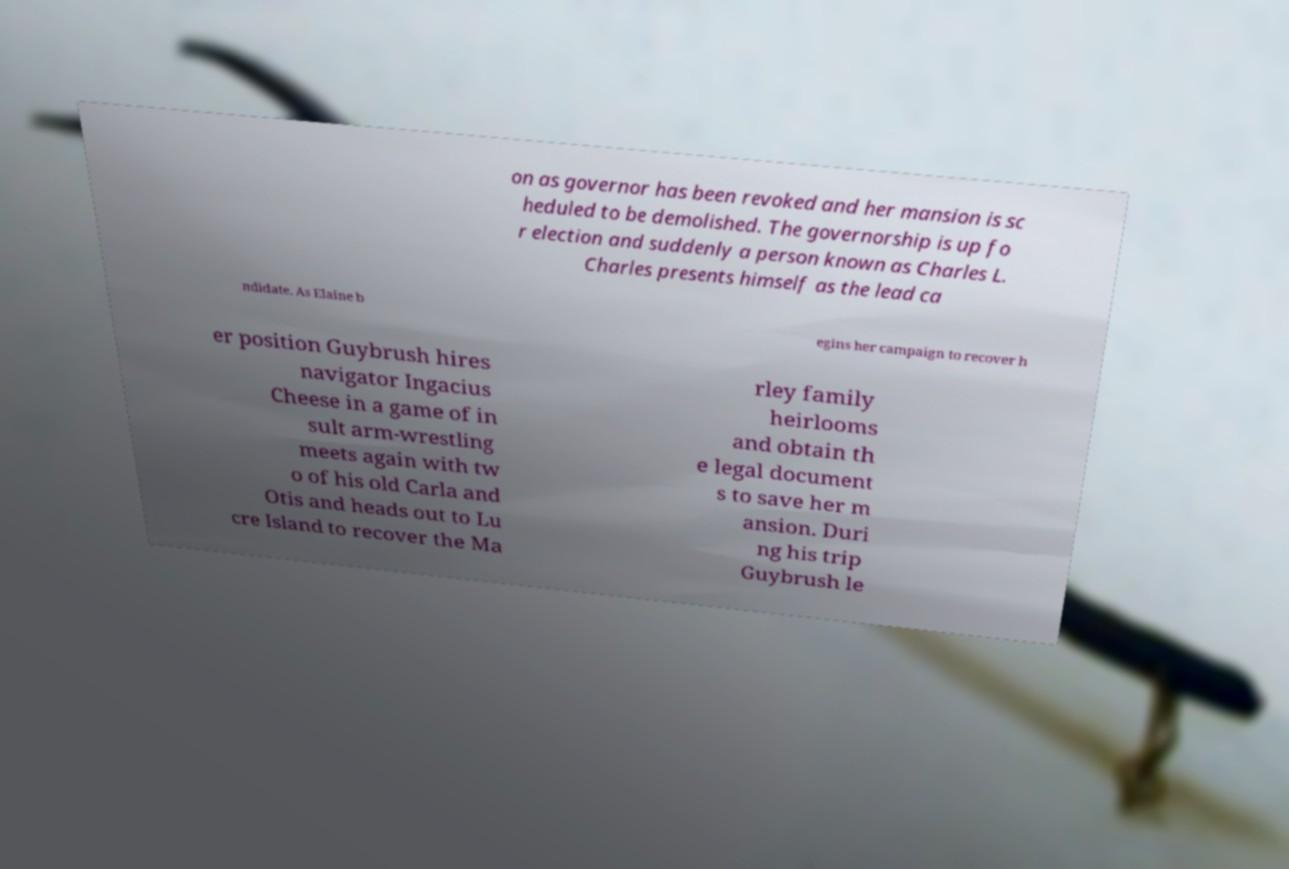Please read and relay the text visible in this image. What does it say? on as governor has been revoked and her mansion is sc heduled to be demolished. The governorship is up fo r election and suddenly a person known as Charles L. Charles presents himself as the lead ca ndidate. As Elaine b egins her campaign to recover h er position Guybrush hires navigator Ingacius Cheese in a game of in sult arm-wrestling meets again with tw o of his old Carla and Otis and heads out to Lu cre Island to recover the Ma rley family heirlooms and obtain th e legal document s to save her m ansion. Duri ng his trip Guybrush le 